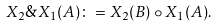Convert formula to latex. <formula><loc_0><loc_0><loc_500><loc_500>X _ { 2 } \& X _ { 1 } ( A ) \colon = X _ { 2 } ( B ) \circ X _ { 1 } ( A ) .</formula> 